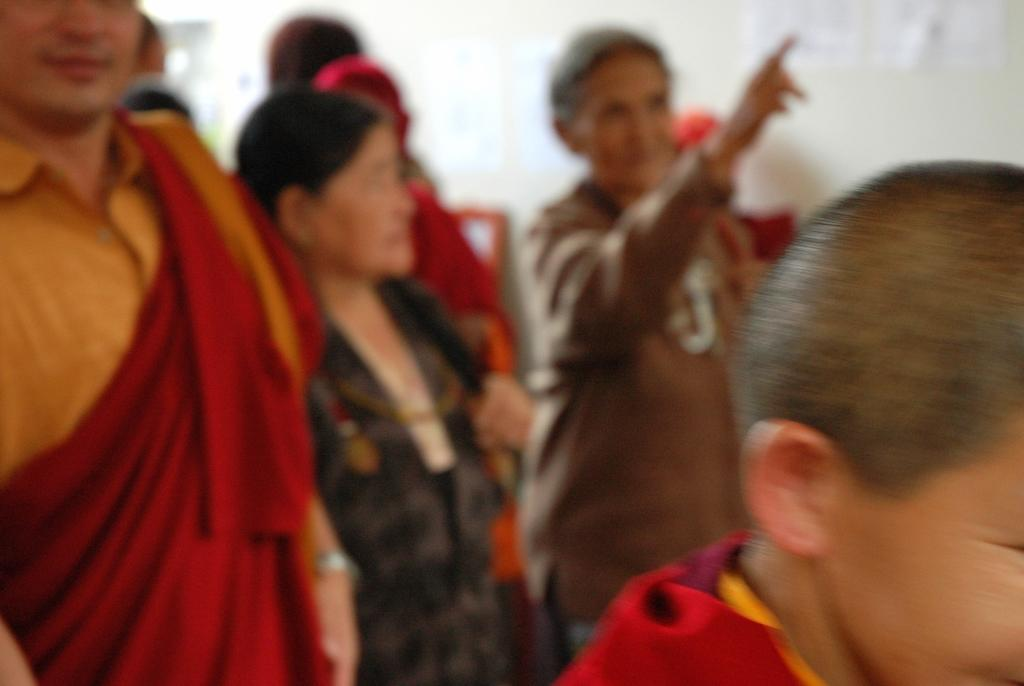What is happening in the image? There are people standing in the image. What can be seen in the background of the image? There is a wall in the background of the image. What type of fish can be seen swimming near the people in the image? There are no fish present in the image; it only features people standing and a wall in the background. 